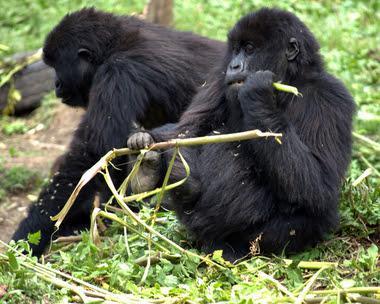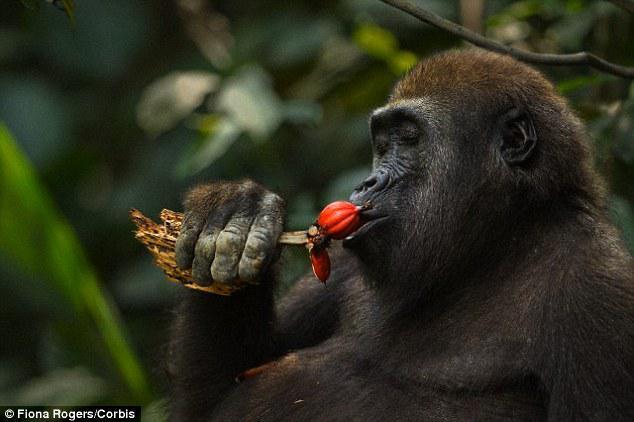The first image is the image on the left, the second image is the image on the right. Assess this claim about the two images: "The gorilla in the right image is chewing on a fibrous stalk.". Correct or not? Answer yes or no. No. The first image is the image on the left, the second image is the image on the right. For the images shown, is this caption "One of the photos contains more than one animal." true? Answer yes or no. Yes. 